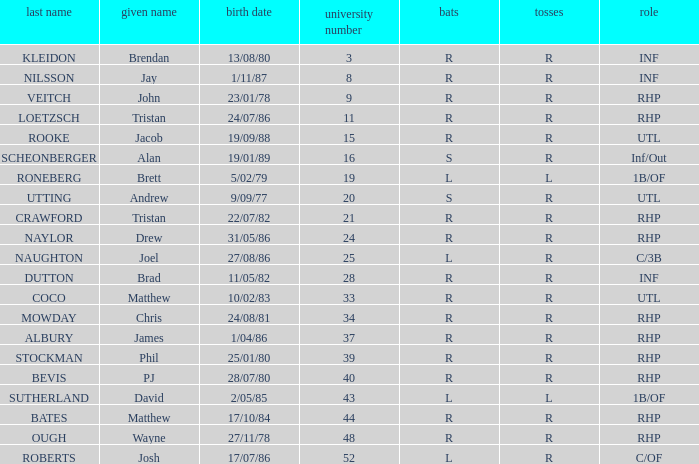How many Uni numbers have Bats of s, and a Position of utl? 1.0. 